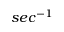<formula> <loc_0><loc_0><loc_500><loc_500>s e c ^ { - 1 }</formula> 